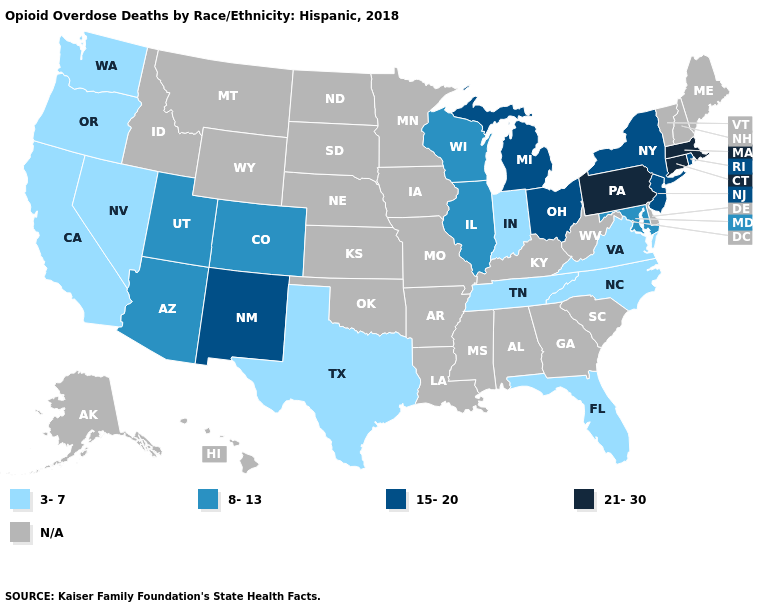Name the states that have a value in the range N/A?
Answer briefly. Alabama, Alaska, Arkansas, Delaware, Georgia, Hawaii, Idaho, Iowa, Kansas, Kentucky, Louisiana, Maine, Minnesota, Mississippi, Missouri, Montana, Nebraska, New Hampshire, North Dakota, Oklahoma, South Carolina, South Dakota, Vermont, West Virginia, Wyoming. What is the value of Louisiana?
Write a very short answer. N/A. Does Connecticut have the highest value in the Northeast?
Quick response, please. Yes. Which states hav the highest value in the MidWest?
Short answer required. Michigan, Ohio. Does the first symbol in the legend represent the smallest category?
Be succinct. Yes. Does North Carolina have the highest value in the USA?
Give a very brief answer. No. Name the states that have a value in the range 15-20?
Keep it brief. Michigan, New Jersey, New Mexico, New York, Ohio, Rhode Island. Does the map have missing data?
Answer briefly. Yes. What is the value of Kentucky?
Short answer required. N/A. What is the value of Tennessee?
Be succinct. 3-7. What is the value of Colorado?
Keep it brief. 8-13. What is the highest value in the West ?
Keep it brief. 15-20. Does California have the lowest value in the USA?
Give a very brief answer. Yes. Name the states that have a value in the range 3-7?
Answer briefly. California, Florida, Indiana, Nevada, North Carolina, Oregon, Tennessee, Texas, Virginia, Washington. 